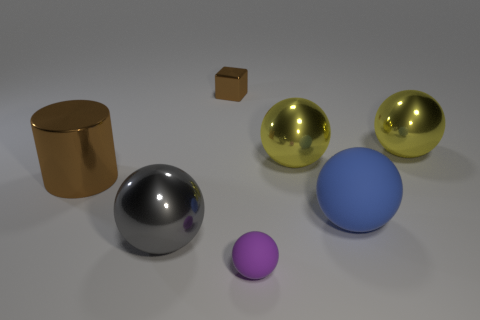Subtract all purple spheres. How many spheres are left? 4 Subtract all large shiny spheres. How many spheres are left? 2 Add 2 small gray shiny things. How many objects exist? 9 Add 1 gray balls. How many gray balls are left? 2 Add 7 big blue spheres. How many big blue spheres exist? 8 Subtract 1 brown cylinders. How many objects are left? 6 Subtract all blocks. How many objects are left? 6 Subtract 3 balls. How many balls are left? 2 Subtract all blue balls. Subtract all red cylinders. How many balls are left? 4 Subtract all purple cylinders. How many yellow balls are left? 2 